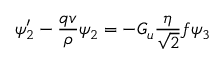<formula> <loc_0><loc_0><loc_500><loc_500>\psi _ { 2 } ^ { \prime } - { \frac { q v } { \rho } } \psi _ { 2 } = - G _ { u } { \frac { \eta } { \sqrt { 2 } } } f \psi _ { 3 }</formula> 